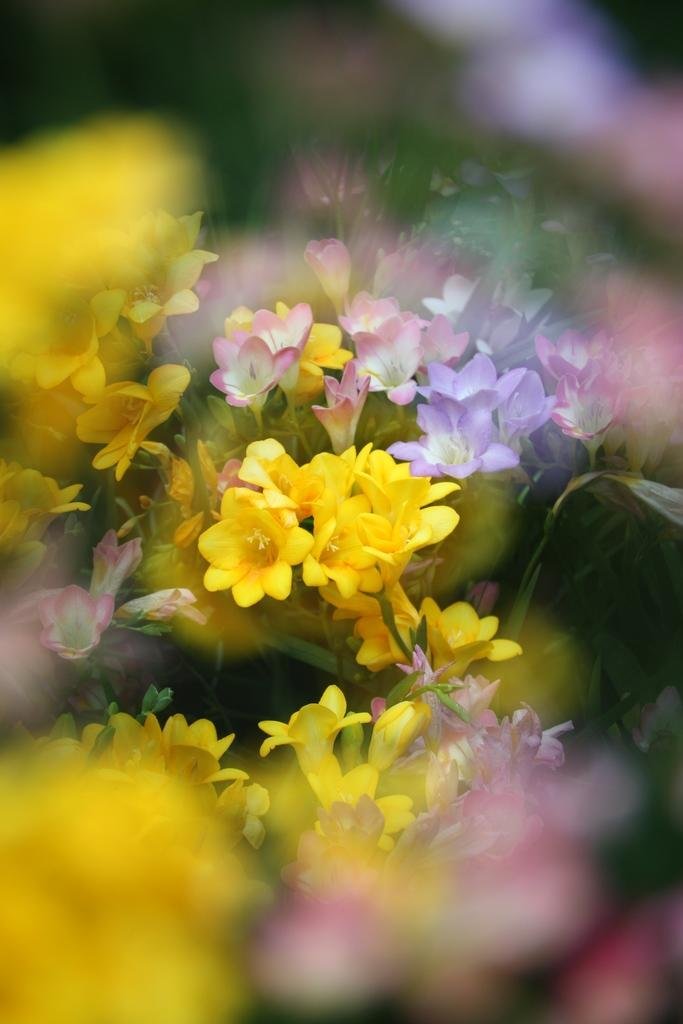What type of plants can be seen in the image? There are flowers in the image. What colors are the flowers? Some flowers are yellow, pink, and lavender. Are there any other flowers besides the yellow, pink, and lavender ones? Yes, there are more flowers around the yellow, pink, and lavender flowers. What is the growth stage of some flowers in the image? There are some buds in the image. What time of day is depicted in the image? The time of day is not mentioned or depicted in the image. What type of expansion is occurring in the image? There is no expansion occurring in the image; it is a still image of flowers. 